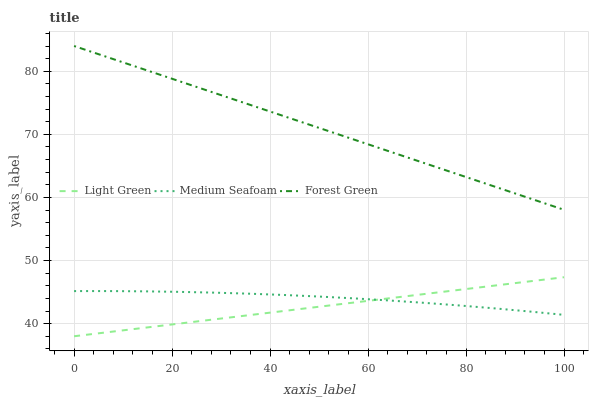Does Light Green have the minimum area under the curve?
Answer yes or no. Yes. Does Forest Green have the maximum area under the curve?
Answer yes or no. Yes. Does Medium Seafoam have the minimum area under the curve?
Answer yes or no. No. Does Medium Seafoam have the maximum area under the curve?
Answer yes or no. No. Is Light Green the smoothest?
Answer yes or no. Yes. Is Medium Seafoam the roughest?
Answer yes or no. Yes. Is Medium Seafoam the smoothest?
Answer yes or no. No. Is Light Green the roughest?
Answer yes or no. No. Does Light Green have the lowest value?
Answer yes or no. Yes. Does Medium Seafoam have the lowest value?
Answer yes or no. No. Does Forest Green have the highest value?
Answer yes or no. Yes. Does Light Green have the highest value?
Answer yes or no. No. Is Medium Seafoam less than Forest Green?
Answer yes or no. Yes. Is Forest Green greater than Medium Seafoam?
Answer yes or no. Yes. Does Light Green intersect Medium Seafoam?
Answer yes or no. Yes. Is Light Green less than Medium Seafoam?
Answer yes or no. No. Is Light Green greater than Medium Seafoam?
Answer yes or no. No. Does Medium Seafoam intersect Forest Green?
Answer yes or no. No. 